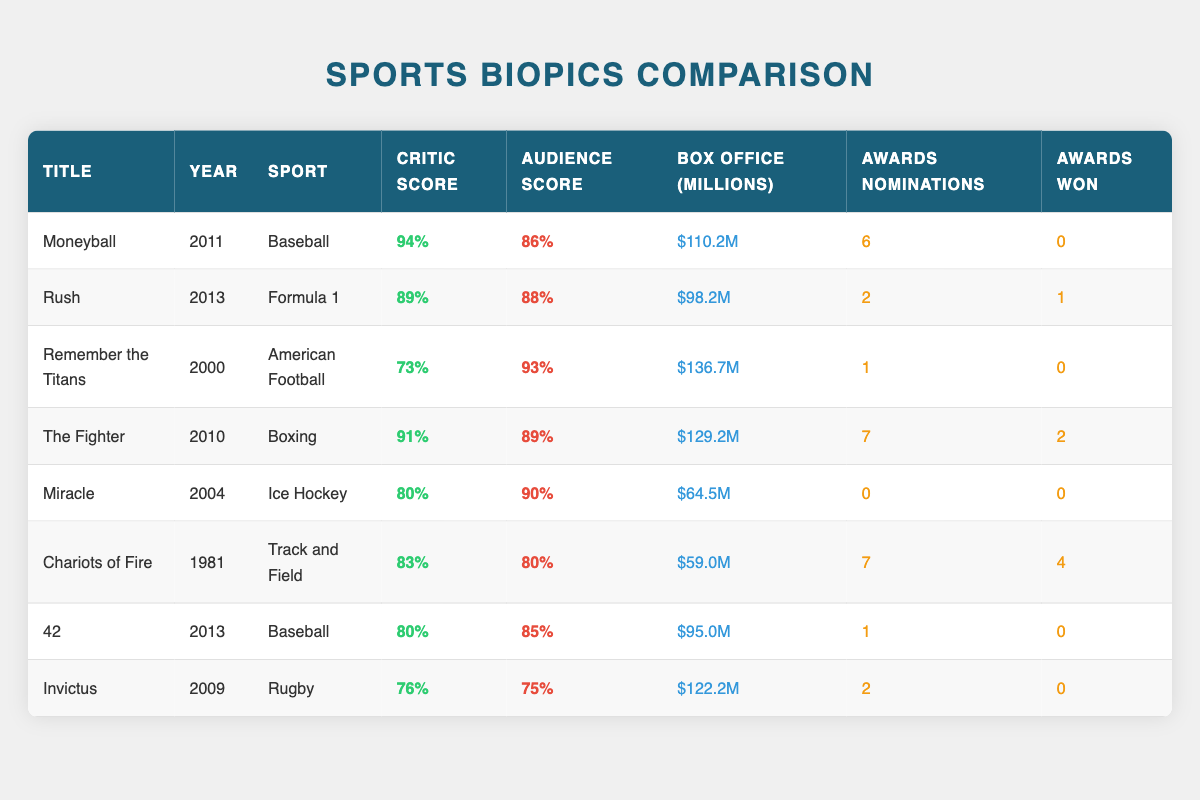What is the title of the sports biopic with the highest critic score? The highest critic score in the table is 94%, which belongs to "Moneyball."
Answer: Moneyball Which sports biopic has the largest box office gross? The box office gross for "Remember the Titans" is $136.7 million, which is the highest in the table compared to others.
Answer: $136.7 million Did "Invictus" win any awards? According to the table, "Invictus" won 0 awards, indicating that it did not win any accolades.
Answer: No Which sports biopic has the highest audience score? "Remember the Titans" has the highest audience score at 93%, surpassing all other films in the table.
Answer: 93% What is the total number of awards won by "Chariots of Fire" and "The Fighter"? "Chariots of Fire" won 4 awards and "The Fighter" won 2 awards, summing them gives 4 + 2 = 6 awards total.
Answer: 6 awards What was the critic score of the biopic "42"? The table indicates that the critic score for "42" is 80%.
Answer: 80% Is it true that "Rush" had more awards won than "Invictus"? "Rush" won 1 award while "Invictus" won 0 awards, making the statement true since 1 is greater than 0.
Answer: Yes Calculate the average audience score of the sports biopics listed in the table. The audience scores to calculate the average are 86, 88, 93, 89, 90, 80, 85, and 75. Their sum is 86 + 88 + 93 + 89 + 90 + 80 + 85 + 75 = 696 and we divide by the total of 8 films: 696 / 8 = 87.
Answer: 87 Which sport appears most frequently in the table? By reviewing the table, "Baseball" shows up twice in the films "Moneyball" and "42," making it the sport that appears most frequently.
Answer: Baseball 